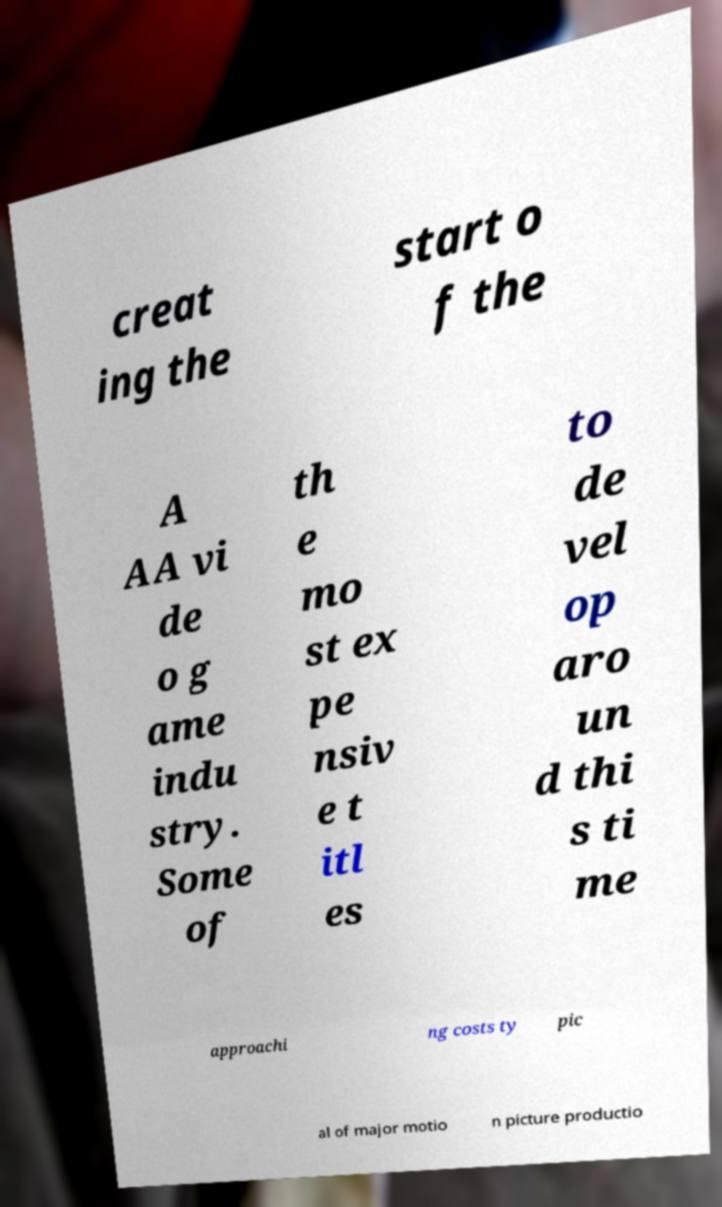There's text embedded in this image that I need extracted. Can you transcribe it verbatim? creat ing the start o f the A AA vi de o g ame indu stry. Some of th e mo st ex pe nsiv e t itl es to de vel op aro un d thi s ti me approachi ng costs ty pic al of major motio n picture productio 